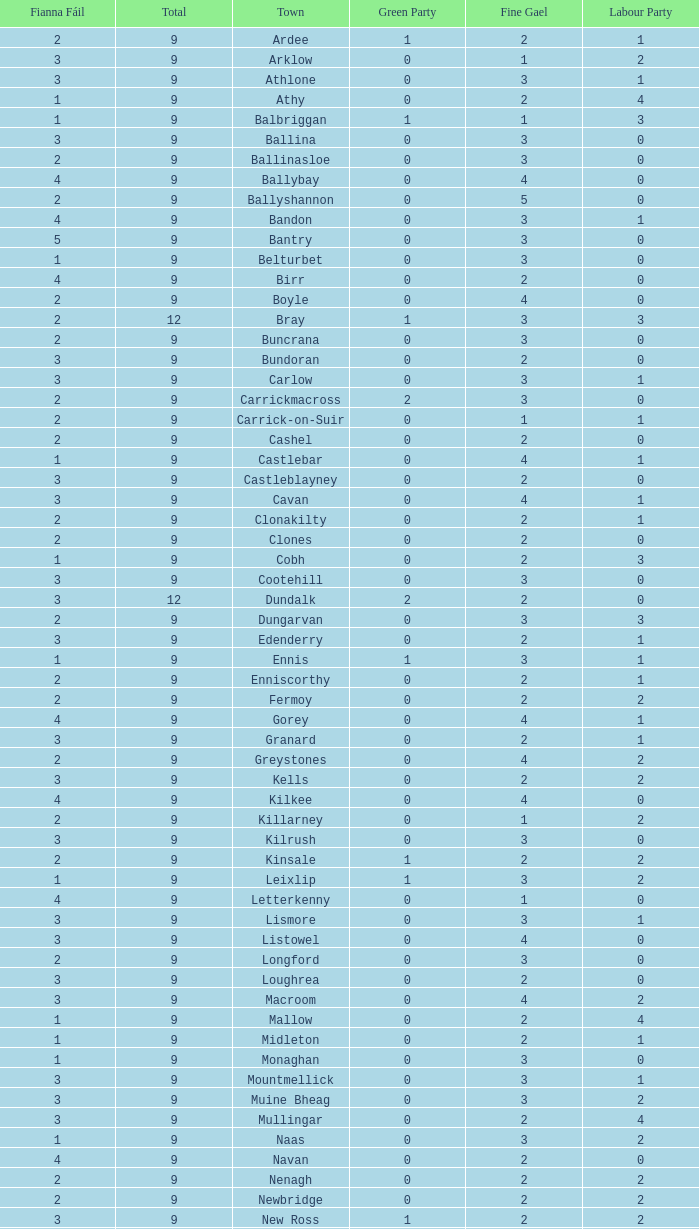How many are in the Labour Party of a Fianna Fail of 3 with a total higher than 9 and more than 2 in the Green Party? None. 